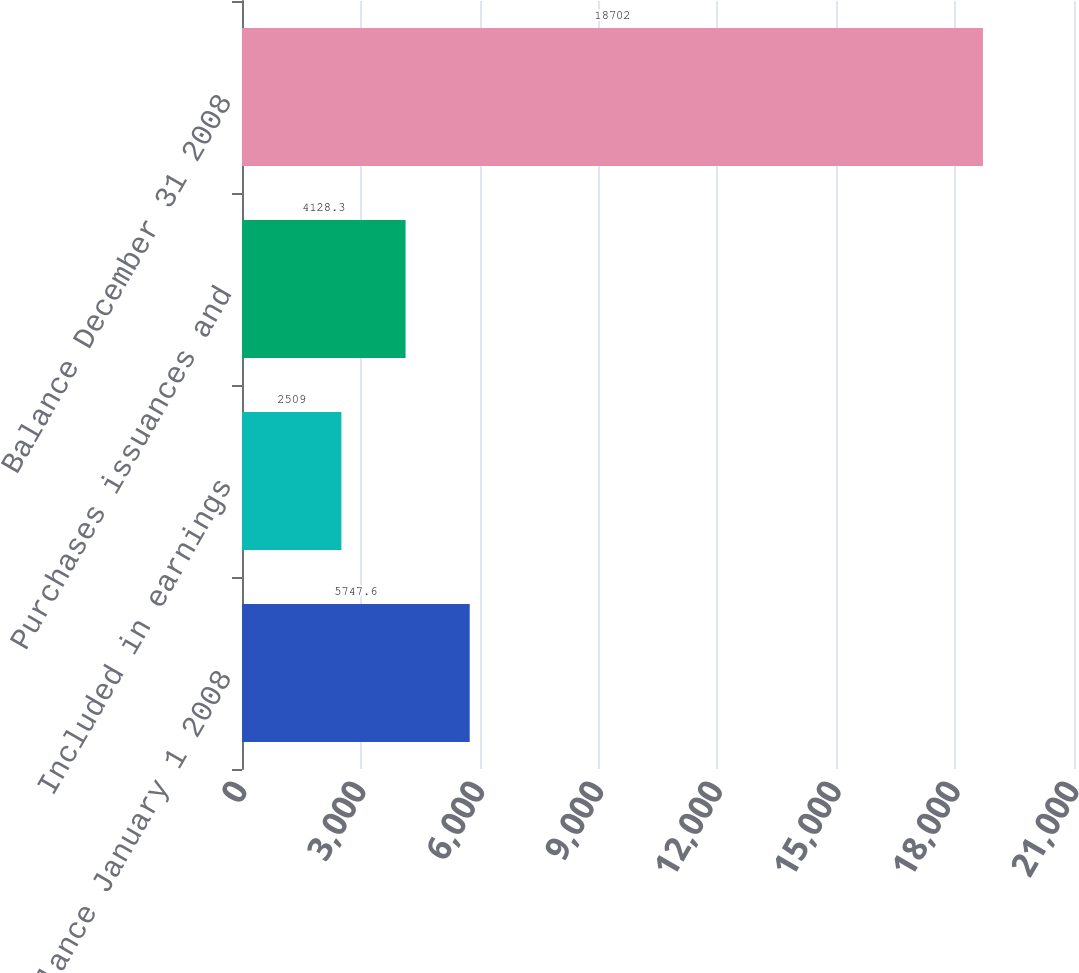Convert chart to OTSL. <chart><loc_0><loc_0><loc_500><loc_500><bar_chart><fcel>Balance January 1 2008<fcel>Included in earnings<fcel>Purchases issuances and<fcel>Balance December 31 2008<nl><fcel>5747.6<fcel>2509<fcel>4128.3<fcel>18702<nl></chart> 